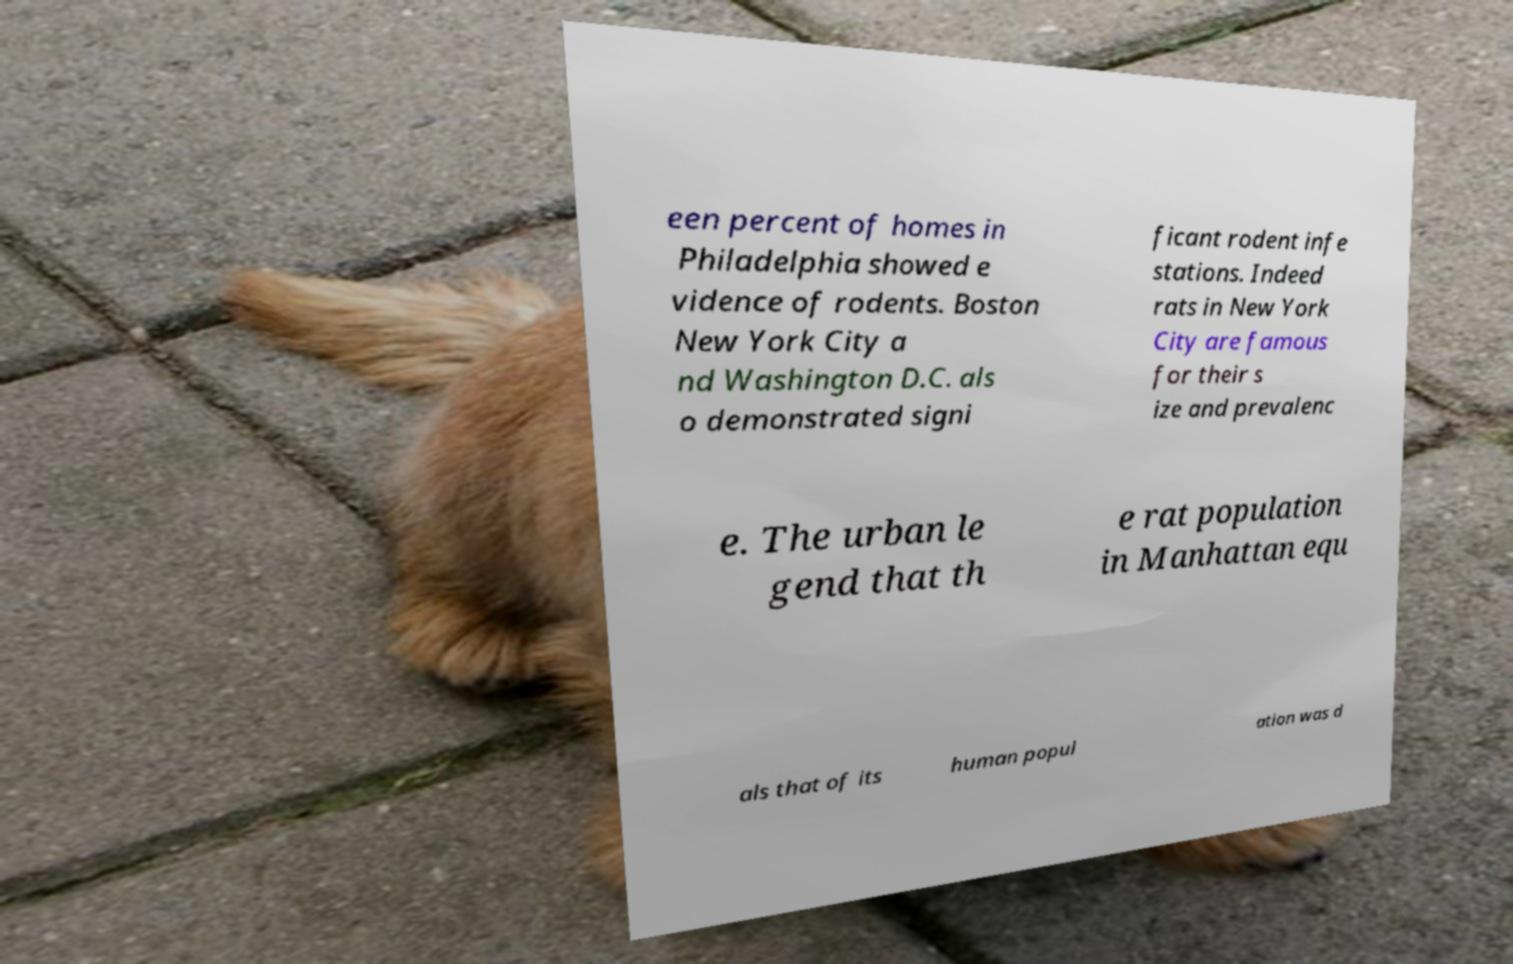Please identify and transcribe the text found in this image. een percent of homes in Philadelphia showed e vidence of rodents. Boston New York City a nd Washington D.C. als o demonstrated signi ficant rodent infe stations. Indeed rats in New York City are famous for their s ize and prevalenc e. The urban le gend that th e rat population in Manhattan equ als that of its human popul ation was d 